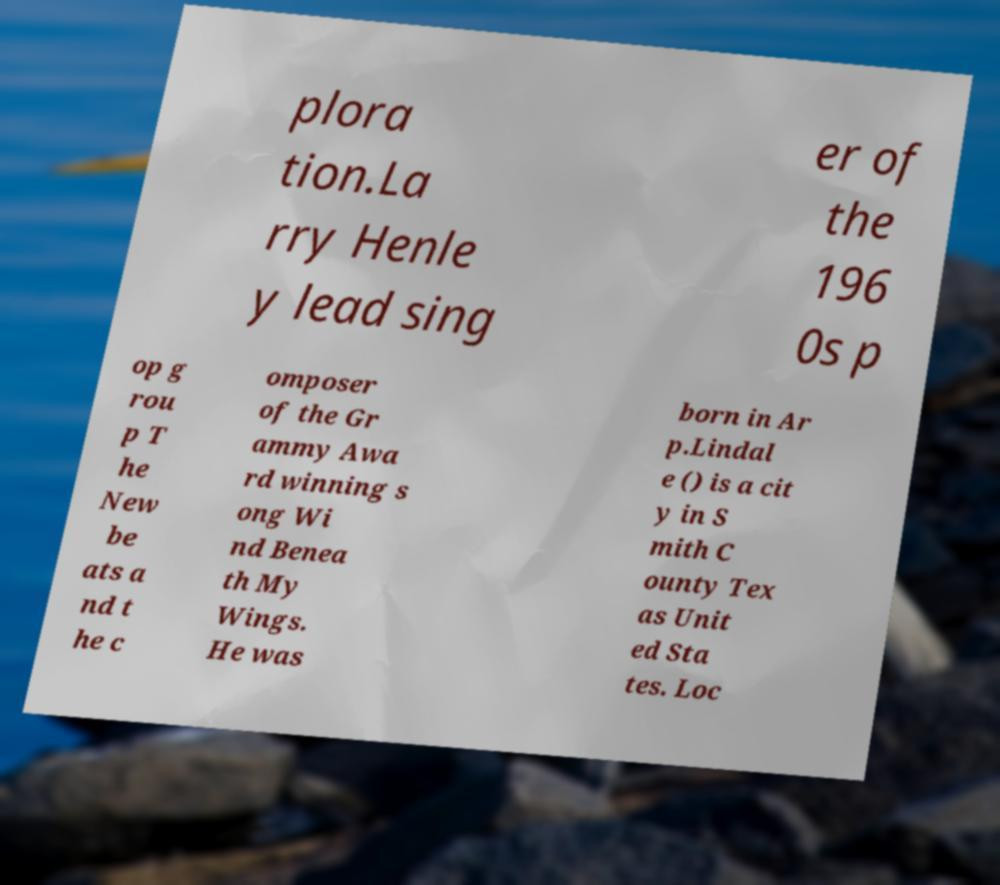There's text embedded in this image that I need extracted. Can you transcribe it verbatim? plora tion.La rry Henle y lead sing er of the 196 0s p op g rou p T he New be ats a nd t he c omposer of the Gr ammy Awa rd winning s ong Wi nd Benea th My Wings. He was born in Ar p.Lindal e () is a cit y in S mith C ounty Tex as Unit ed Sta tes. Loc 